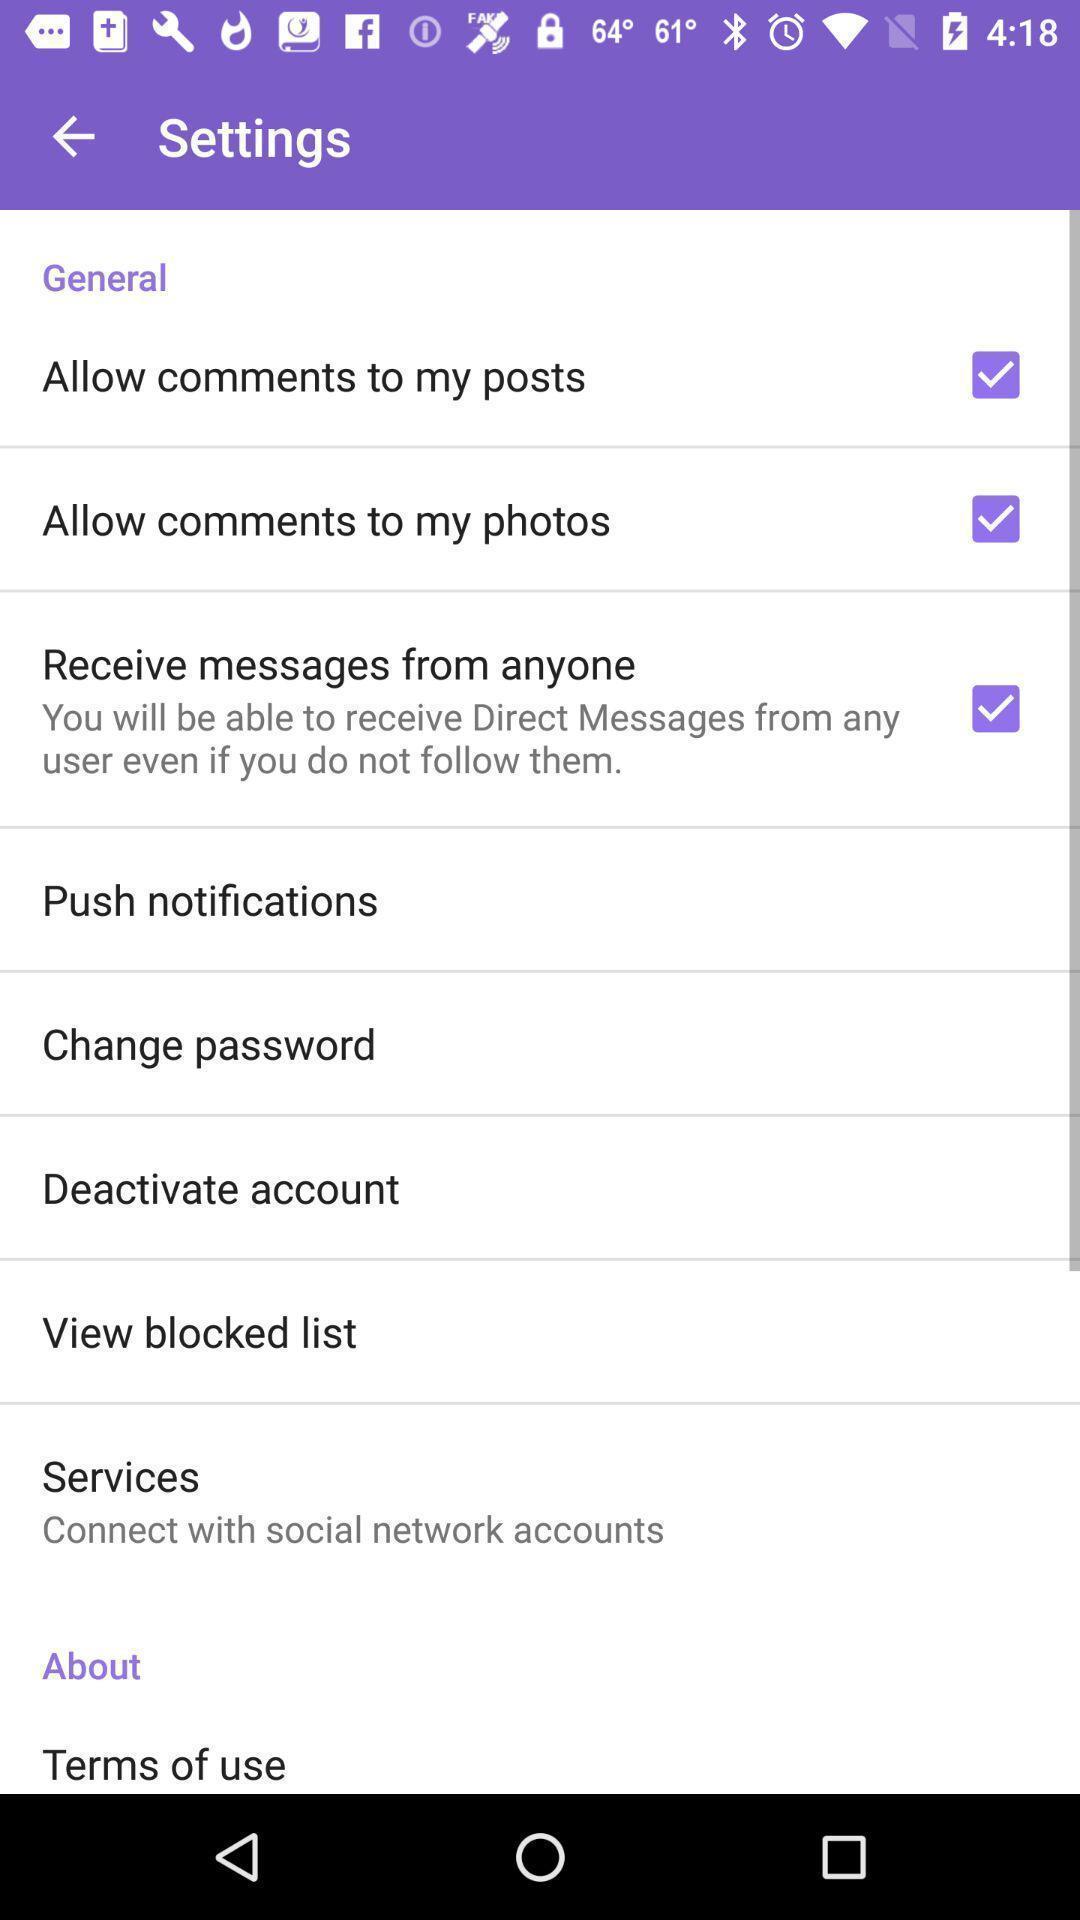Tell me about the visual elements in this screen capture. Settings page displayed. 